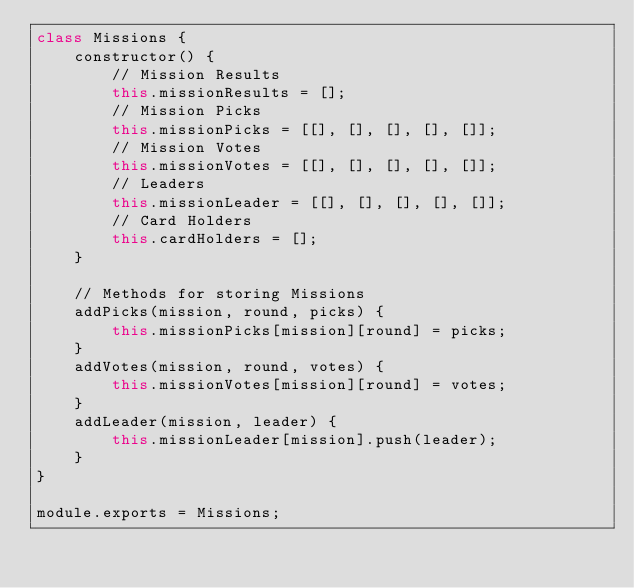<code> <loc_0><loc_0><loc_500><loc_500><_JavaScript_>class Missions {
    constructor() {
        // Mission Results
        this.missionResults = [];
        // Mission Picks
        this.missionPicks = [[], [], [], [], []];
        // Mission Votes
        this.missionVotes = [[], [], [], [], []];
        // Leaders
        this.missionLeader = [[], [], [], [], []];
        // Card Holders
        this.cardHolders = [];
    }

    // Methods for storing Missions
    addPicks(mission, round, picks) {
        this.missionPicks[mission][round] = picks;
    }
    addVotes(mission, round, votes) {
        this.missionVotes[mission][round] = votes;
    }
    addLeader(mission, leader) {
        this.missionLeader[mission].push(leader);
    }
}

module.exports = Missions;
</code> 